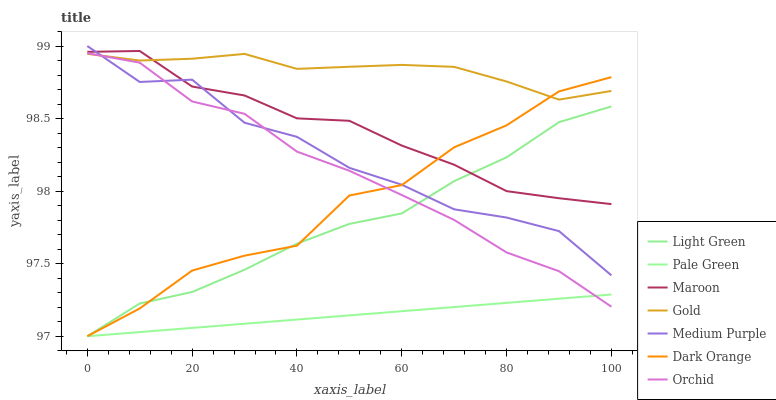Does Maroon have the minimum area under the curve?
Answer yes or no. No. Does Maroon have the maximum area under the curve?
Answer yes or no. No. Is Gold the smoothest?
Answer yes or no. No. Is Gold the roughest?
Answer yes or no. No. Does Maroon have the lowest value?
Answer yes or no. No. Does Gold have the highest value?
Answer yes or no. No. Is Orchid less than Maroon?
Answer yes or no. Yes. Is Maroon greater than Orchid?
Answer yes or no. Yes. Does Orchid intersect Maroon?
Answer yes or no. No. 